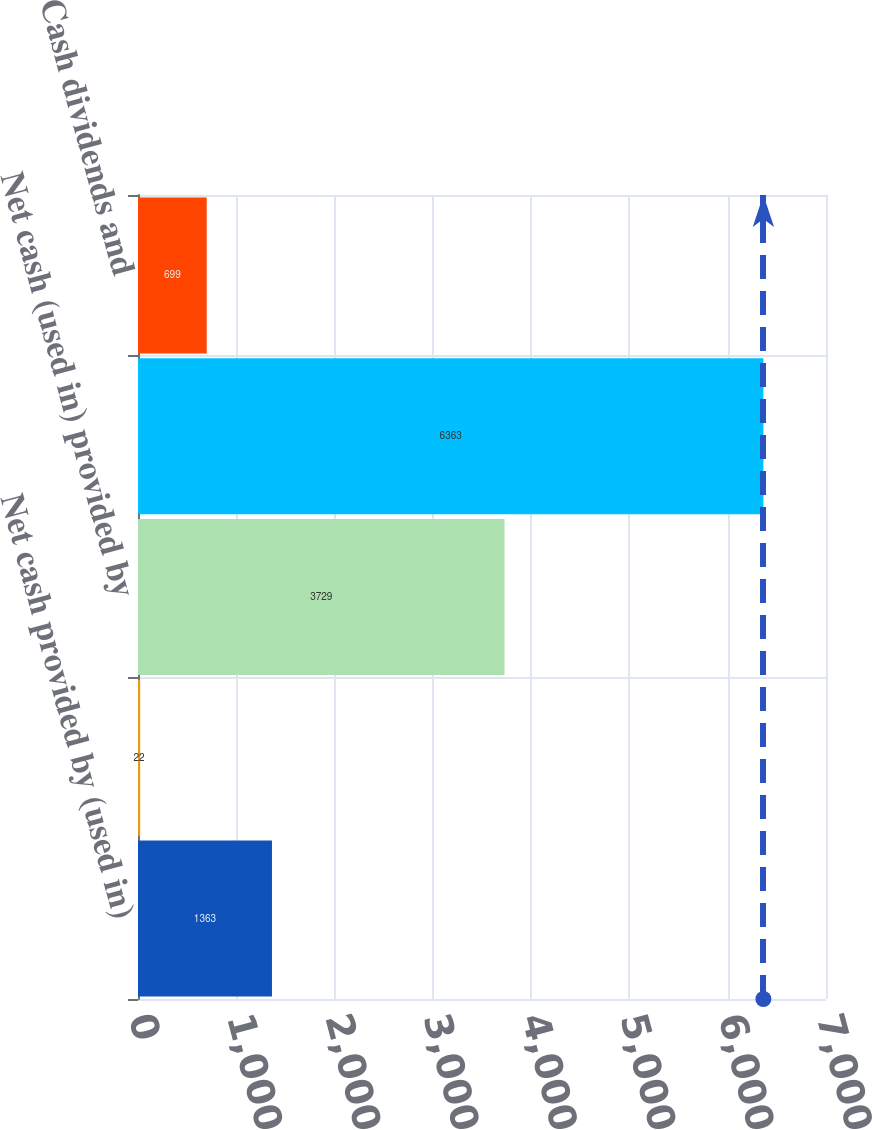<chart> <loc_0><loc_0><loc_500><loc_500><bar_chart><fcel>Net cash provided by (used in)<fcel>Other net<fcel>Net cash (used in) provided by<fcel>Asset sales and other net<fcel>Cash dividends and<nl><fcel>1363<fcel>22<fcel>3729<fcel>6363<fcel>699<nl></chart> 